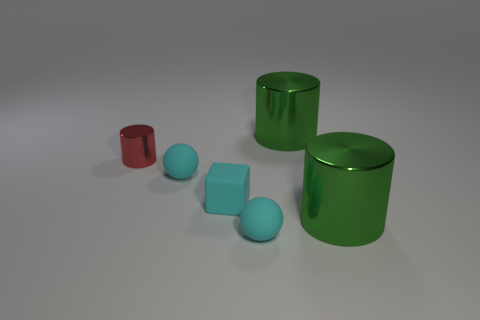There is a cyan matte object right of the block; what shape is it?
Offer a terse response. Sphere. Do the green metallic object that is in front of the red shiny cylinder and the tiny red shiny object have the same size?
Keep it short and to the point. No. There is a thing that is on the left side of the cyan cube and in front of the tiny red shiny thing; what is its size?
Your answer should be compact. Small. How many cylinders have the same color as the small cube?
Provide a succinct answer. 0. Are there an equal number of tiny shiny cylinders in front of the tiny cube and matte things?
Your answer should be compact. No. What color is the tiny metal object?
Give a very brief answer. Red. Is there a metallic object of the same size as the cube?
Give a very brief answer. Yes. There is a red thing that is the same size as the matte block; what is its shape?
Offer a very short reply. Cylinder. Is there another metal thing of the same shape as the small red shiny thing?
Keep it short and to the point. Yes. There is a large metal thing that is in front of the green cylinder that is behind the tiny red cylinder; what shape is it?
Provide a succinct answer. Cylinder. 